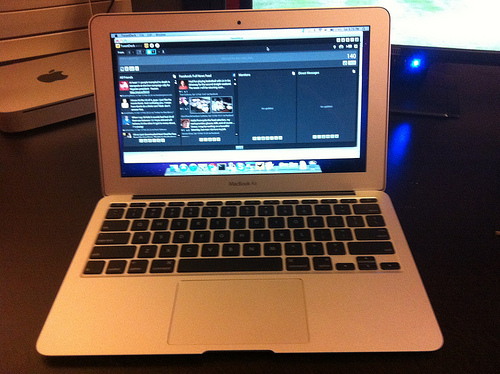<image>
Is there a laptop in front of the mobile? Yes. The laptop is positioned in front of the mobile, appearing closer to the camera viewpoint. 